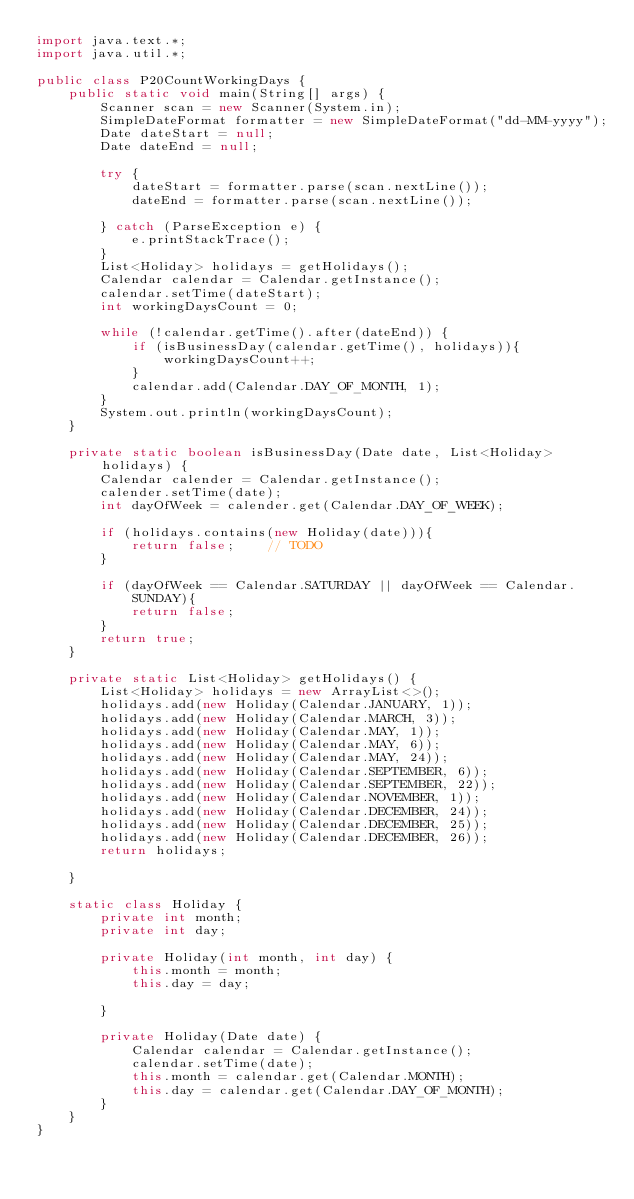<code> <loc_0><loc_0><loc_500><loc_500><_Java_>import java.text.*;
import java.util.*;

public class P20CountWorkingDays {
    public static void main(String[] args) {
        Scanner scan = new Scanner(System.in);
        SimpleDateFormat formatter = new SimpleDateFormat("dd-MM-yyyy");
        Date dateStart = null;
        Date dateEnd = null;

        try {
            dateStart = formatter.parse(scan.nextLine());
            dateEnd = formatter.parse(scan.nextLine());

        } catch (ParseException e) {
            e.printStackTrace();
        }
        List<Holiday> holidays = getHolidays();
        Calendar calendar = Calendar.getInstance();
        calendar.setTime(dateStart);
        int workingDaysCount = 0;

        while (!calendar.getTime().after(dateEnd)) {
            if (isBusinessDay(calendar.getTime(), holidays)){
                workingDaysCount++;
            }
            calendar.add(Calendar.DAY_OF_MONTH, 1);
        }
        System.out.println(workingDaysCount);
    }

    private static boolean isBusinessDay(Date date, List<Holiday> holidays) {
        Calendar calender = Calendar.getInstance();
        calender.setTime(date);
        int dayOfWeek = calender.get(Calendar.DAY_OF_WEEK);

        if (holidays.contains(new Holiday(date))){
            return false;    // TODO
        }

        if (dayOfWeek == Calendar.SATURDAY || dayOfWeek == Calendar.SUNDAY){
            return false;
        }
        return true;
    }

    private static List<Holiday> getHolidays() {
        List<Holiday> holidays = new ArrayList<>();
        holidays.add(new Holiday(Calendar.JANUARY, 1));
        holidays.add(new Holiday(Calendar.MARCH, 3));
        holidays.add(new Holiday(Calendar.MAY, 1));
        holidays.add(new Holiday(Calendar.MAY, 6));
        holidays.add(new Holiday(Calendar.MAY, 24));
        holidays.add(new Holiday(Calendar.SEPTEMBER, 6));
        holidays.add(new Holiday(Calendar.SEPTEMBER, 22));
        holidays.add(new Holiday(Calendar.NOVEMBER, 1));
        holidays.add(new Holiday(Calendar.DECEMBER, 24));
        holidays.add(new Holiday(Calendar.DECEMBER, 25));
        holidays.add(new Holiday(Calendar.DECEMBER, 26));
        return holidays;

    }

    static class Holiday {
        private int month;
        private int day;

        private Holiday(int month, int day) {
            this.month = month;
            this.day = day;

        }

        private Holiday(Date date) {
            Calendar calendar = Calendar.getInstance();
            calendar.setTime(date);
            this.month = calendar.get(Calendar.MONTH);
            this.day = calendar.get(Calendar.DAY_OF_MONTH);
        }
    }
}</code> 